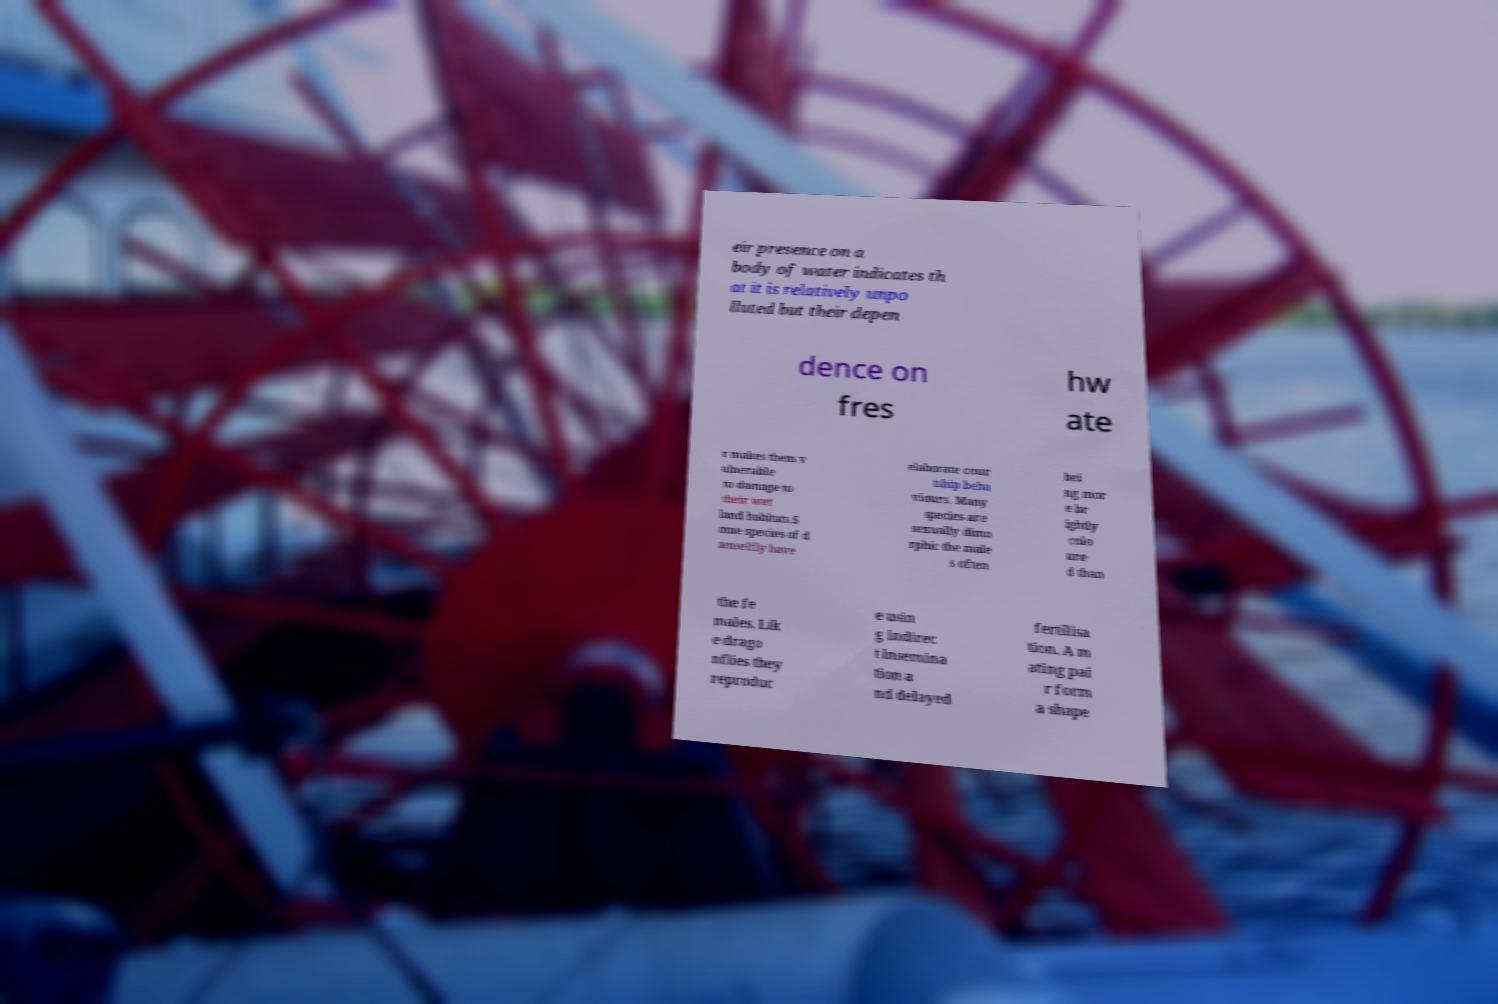Please read and relay the text visible in this image. What does it say? eir presence on a body of water indicates th at it is relatively unpo lluted but their depen dence on fres hw ate r makes them v ulnerable to damage to their wet land habitats.S ome species of d amselfly have elaborate cour tship beha viours. Many species are sexually dimo rphic the male s often bei ng mor e br ightly colo ure d than the fe males. Lik e drago nflies they reproduc e usin g indirec t insemina tion a nd delayed fertilisa tion. A m ating pai r form a shape 